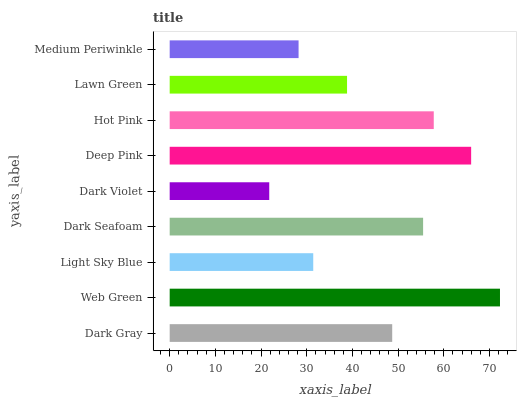Is Dark Violet the minimum?
Answer yes or no. Yes. Is Web Green the maximum?
Answer yes or no. Yes. Is Light Sky Blue the minimum?
Answer yes or no. No. Is Light Sky Blue the maximum?
Answer yes or no. No. Is Web Green greater than Light Sky Blue?
Answer yes or no. Yes. Is Light Sky Blue less than Web Green?
Answer yes or no. Yes. Is Light Sky Blue greater than Web Green?
Answer yes or no. No. Is Web Green less than Light Sky Blue?
Answer yes or no. No. Is Dark Gray the high median?
Answer yes or no. Yes. Is Dark Gray the low median?
Answer yes or no. Yes. Is Hot Pink the high median?
Answer yes or no. No. Is Dark Seafoam the low median?
Answer yes or no. No. 